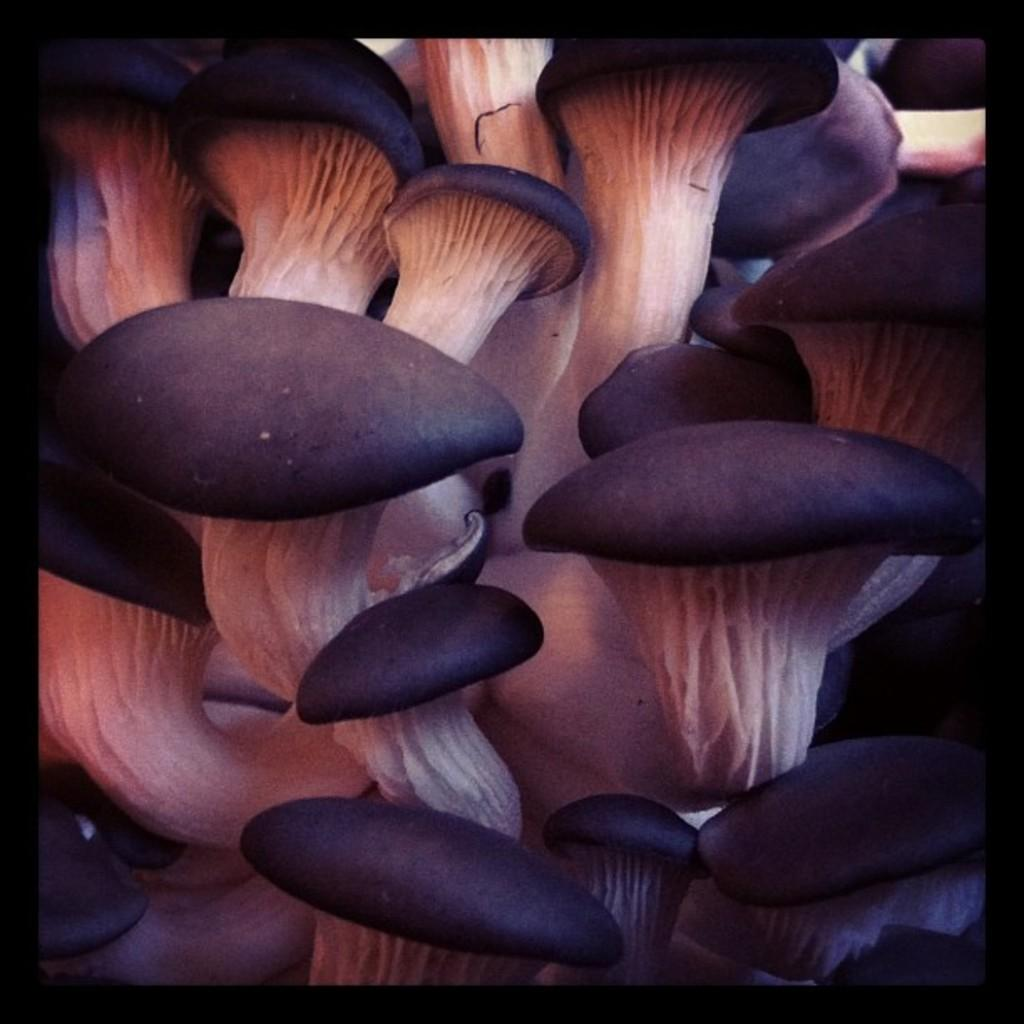What type of fungi can be seen in the image? There are mushrooms in the image. What color are the mushrooms in the image? The mushrooms are black and white in color. How many clover leaves can be seen on the mushrooms in the image? There are no clover leaves present on the mushrooms in the image, as clover leaves are not associated with mushrooms. 